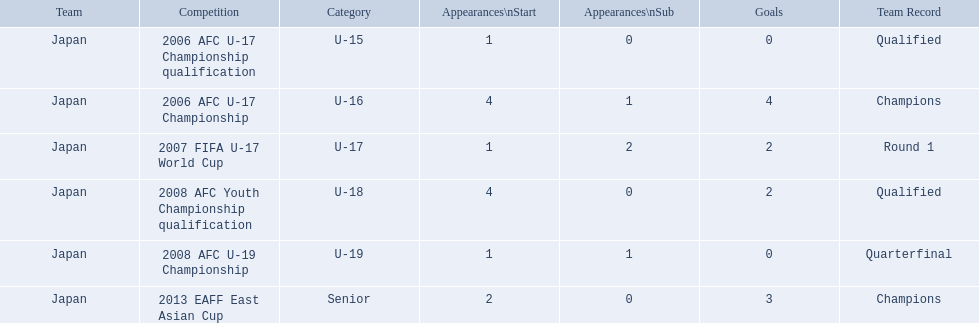How many appearances were there for each competition? 1, 4, 1, 4, 1, 2. How many goals were there for each competition? 0, 4, 2, 2, 0, 3. Which competition(s) has/have the most appearances? 2006 AFC U-17 Championship, 2008 AFC Youth Championship qualification. Which competition(s) has/have the most goals? 2006 AFC U-17 Championship. 